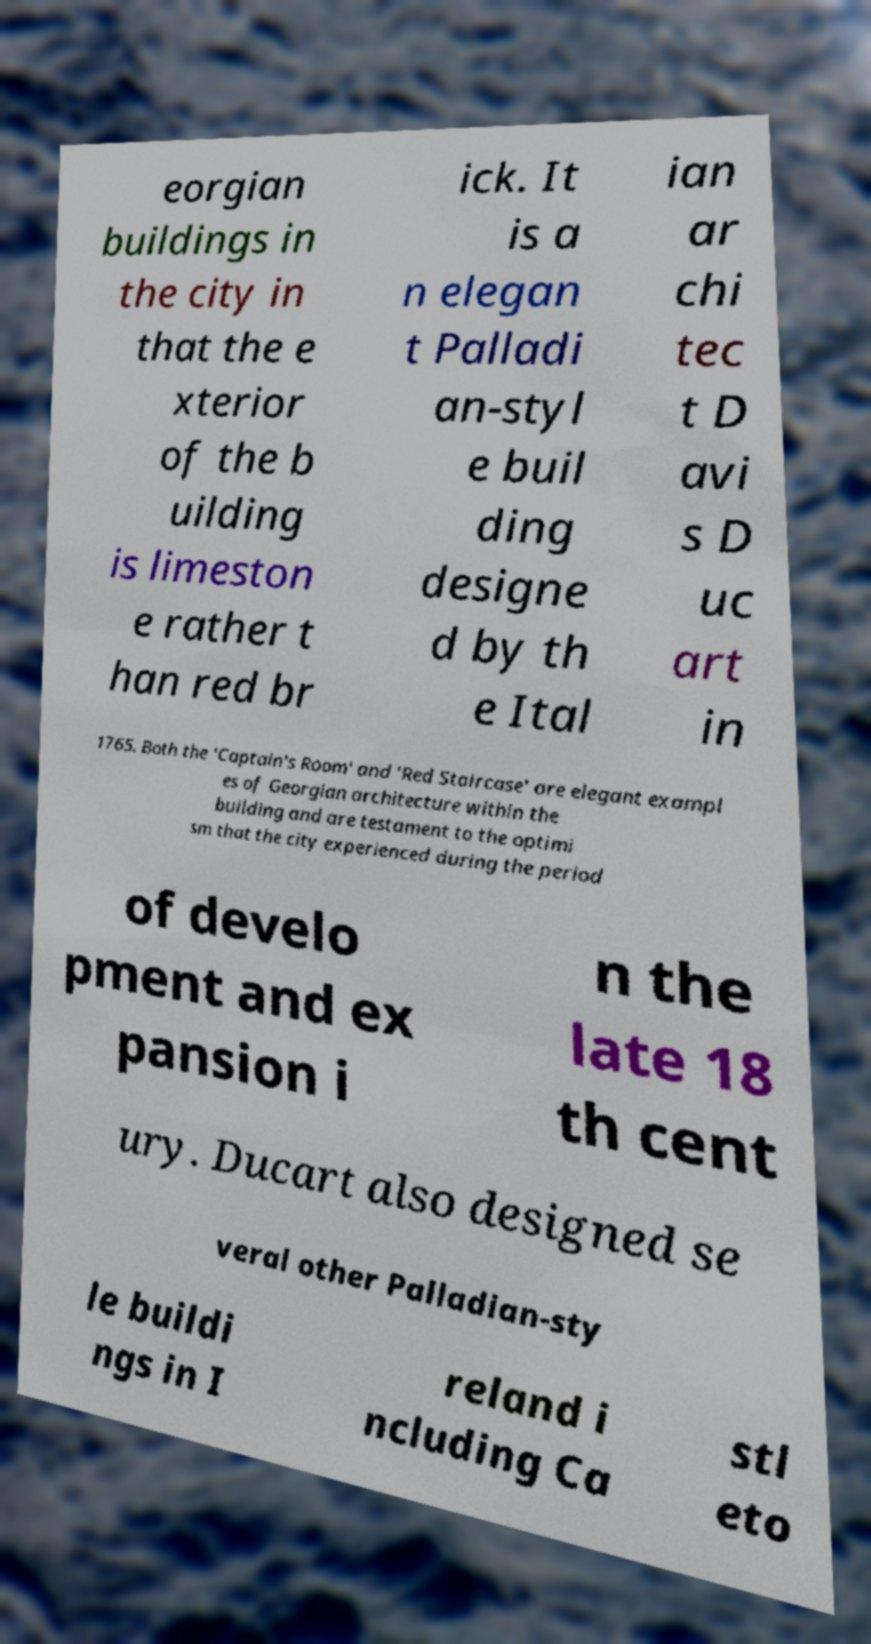Could you assist in decoding the text presented in this image and type it out clearly? eorgian buildings in the city in that the e xterior of the b uilding is limeston e rather t han red br ick. It is a n elegan t Palladi an-styl e buil ding designe d by th e Ital ian ar chi tec t D avi s D uc art in 1765. Both the 'Captain's Room' and 'Red Staircase' are elegant exampl es of Georgian architecture within the building and are testament to the optimi sm that the city experienced during the period of develo pment and ex pansion i n the late 18 th cent ury. Ducart also designed se veral other Palladian-sty le buildi ngs in I reland i ncluding Ca stl eto 